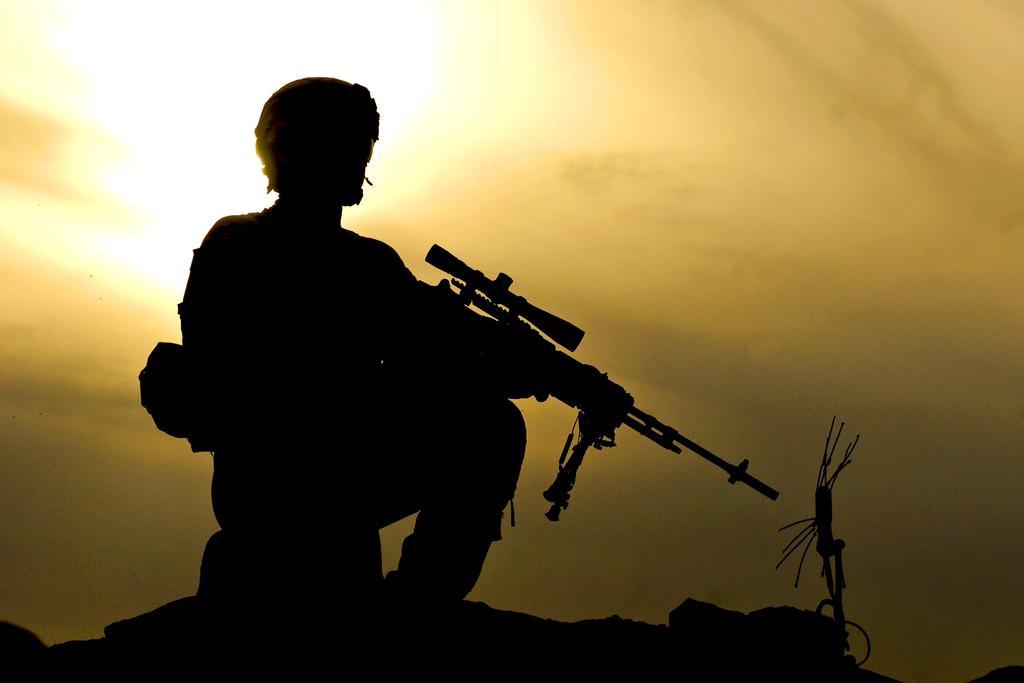How would you summarize this image in a sentence or two? In this picture, there is a man holding a gun. He is sitting on the rock. In the background, there is a sky. 